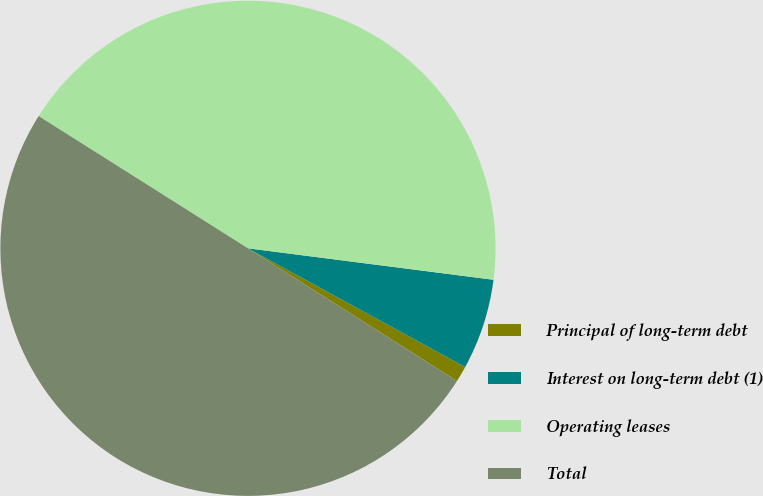<chart> <loc_0><loc_0><loc_500><loc_500><pie_chart><fcel>Principal of long-term debt<fcel>Interest on long-term debt (1)<fcel>Operating leases<fcel>Total<nl><fcel>1.04%<fcel>5.93%<fcel>43.06%<fcel>49.97%<nl></chart> 